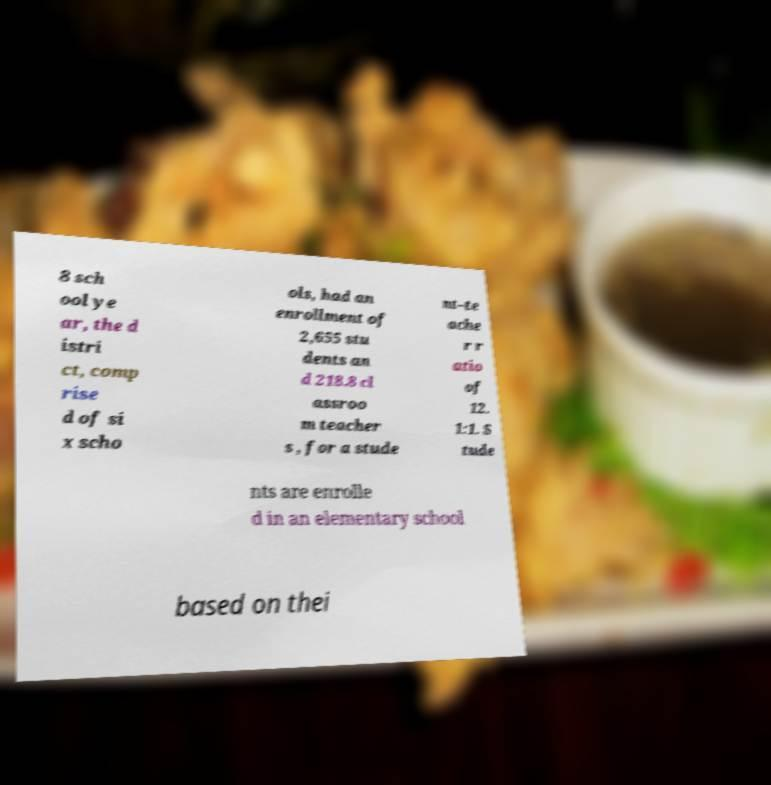Can you accurately transcribe the text from the provided image for me? 8 sch ool ye ar, the d istri ct, comp rise d of si x scho ols, had an enrollment of 2,655 stu dents an d 218.8 cl assroo m teacher s , for a stude nt–te ache r r atio of 12. 1:1. S tude nts are enrolle d in an elementary school based on thei 